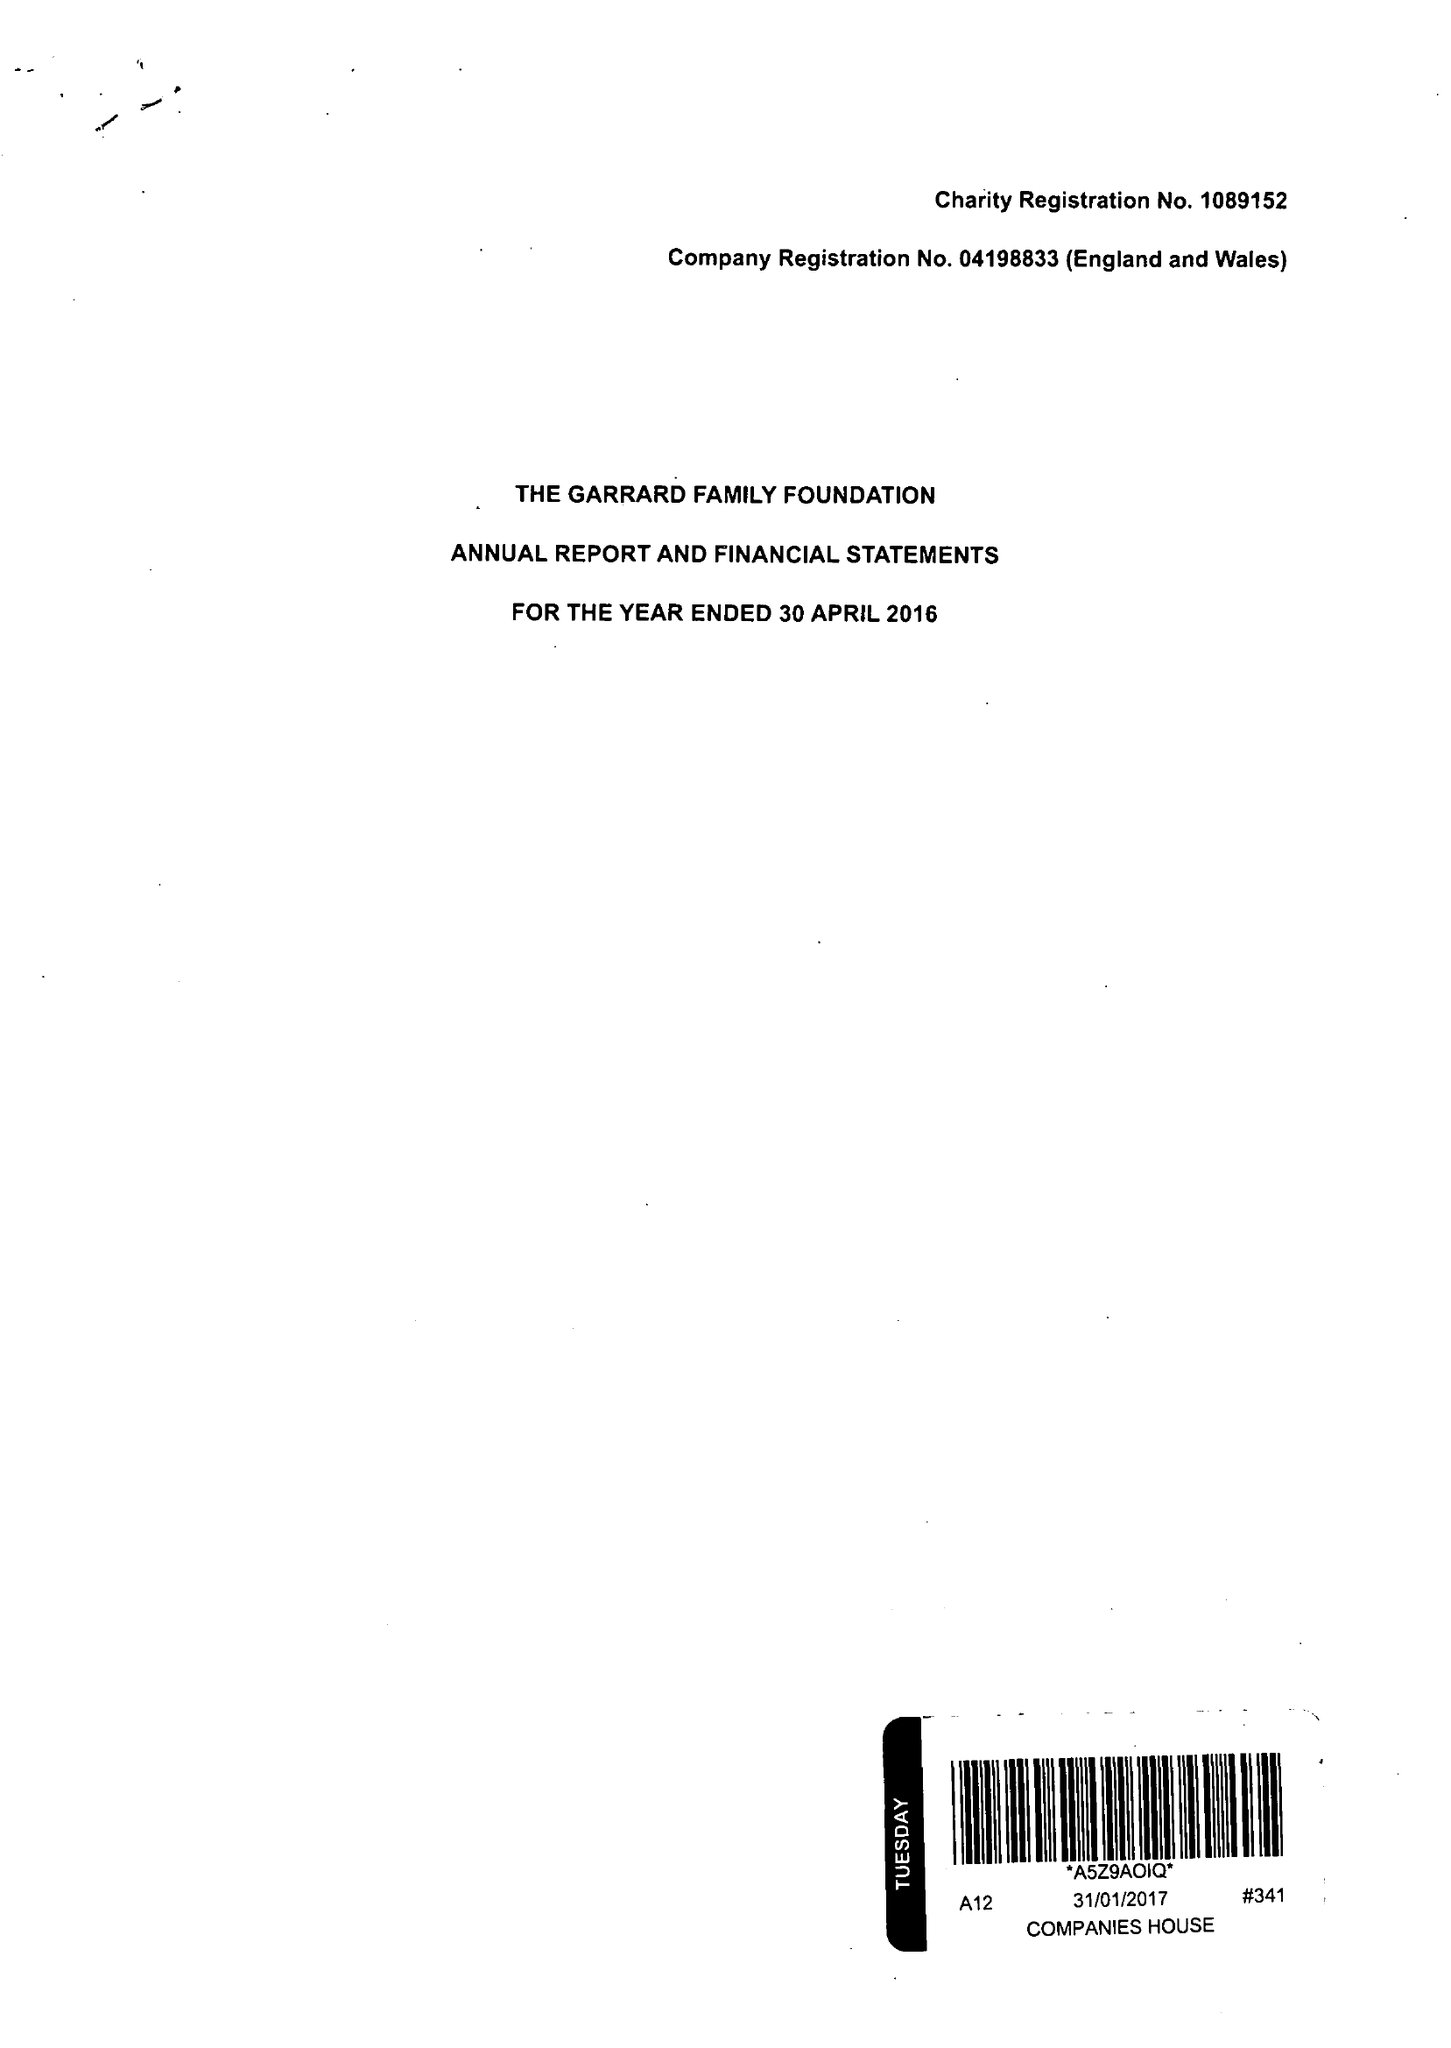What is the value for the address__post_town?
Answer the question using a single word or phrase. LONDON 